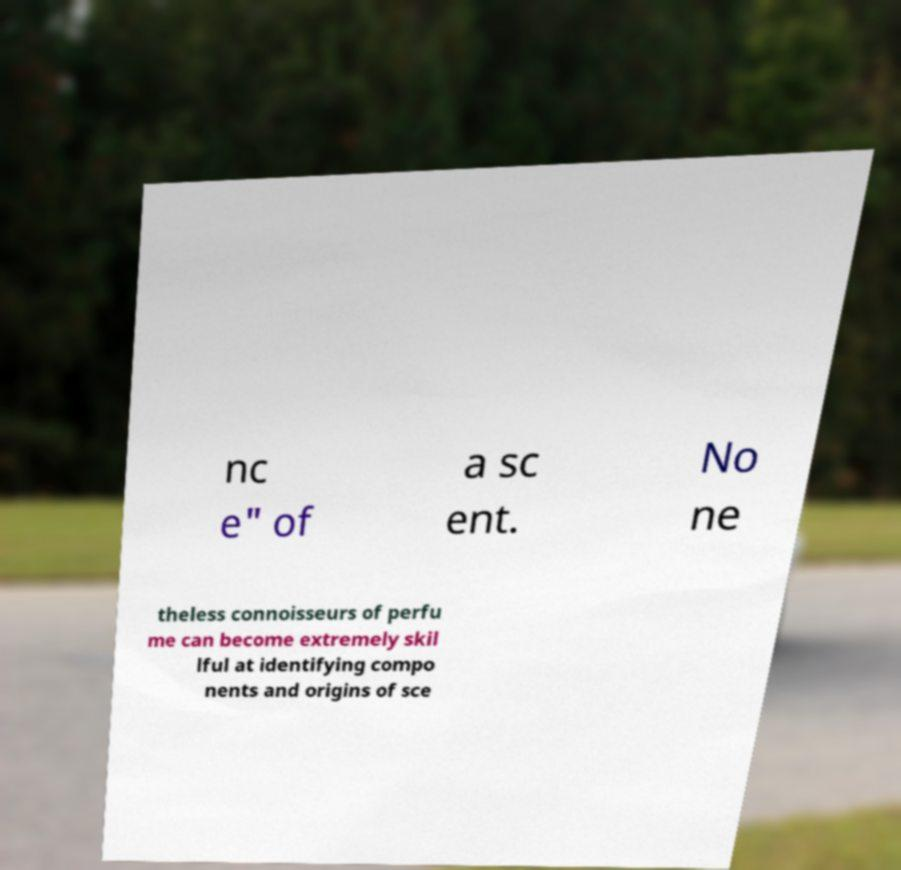Could you assist in decoding the text presented in this image and type it out clearly? nc e" of a sc ent. No ne theless connoisseurs of perfu me can become extremely skil lful at identifying compo nents and origins of sce 